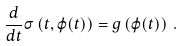<formula> <loc_0><loc_0><loc_500><loc_500>\frac { d } { d t } \sigma \left ( t , \varphi ( t ) \right ) = g \left ( \varphi ( t ) \right ) \, .</formula> 